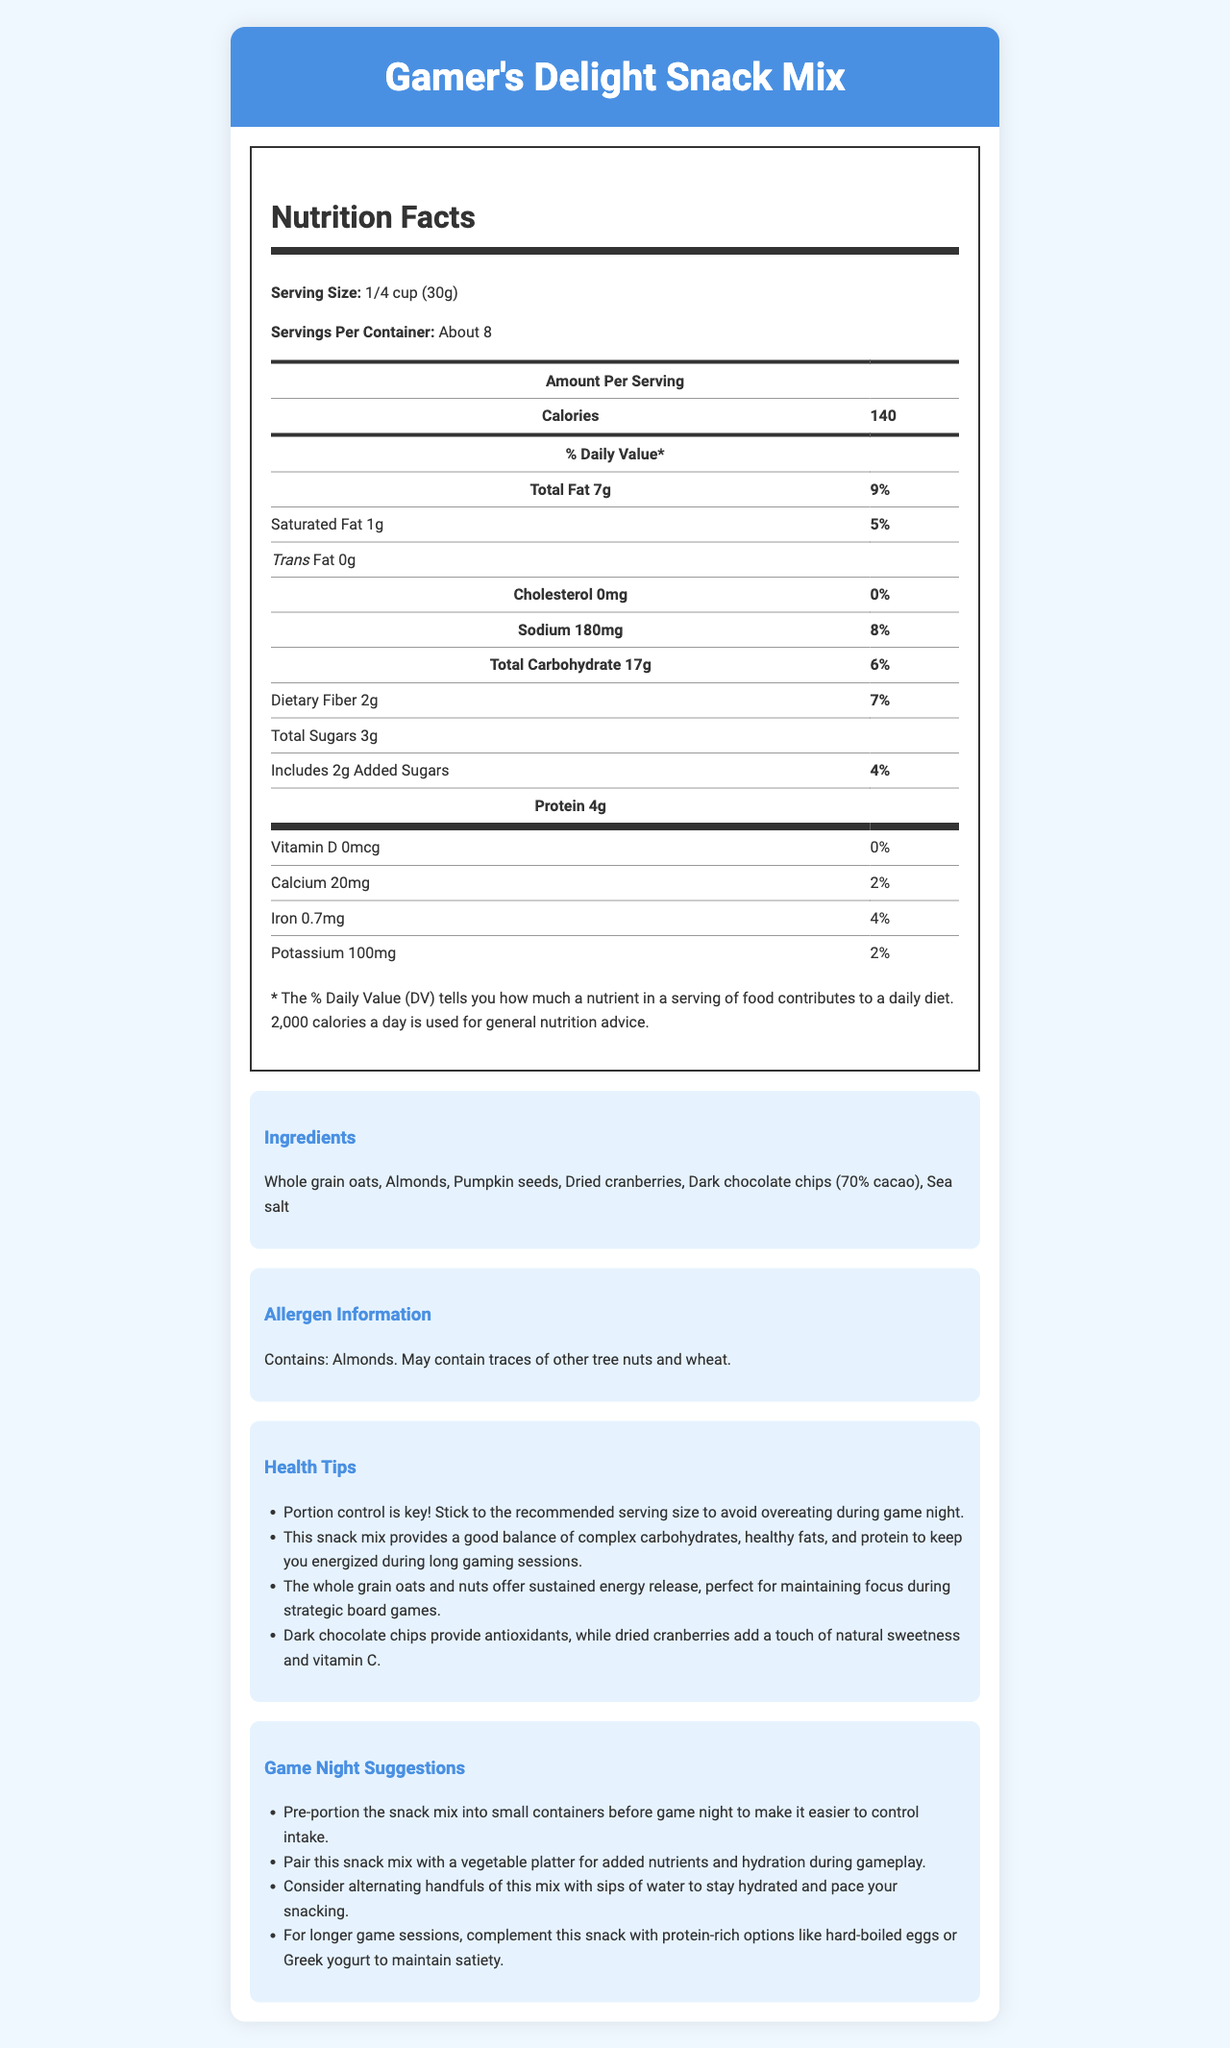What is the serving size for the Gamer's Delight Snack Mix? The serving size is explicitly listed under the nutrition facts section as "1/4 cup (30g)."
Answer: 1/4 cup (30g) How many servings are in one container of the Gamer's Delight Snack Mix? It is stated in the nutrition facts section that there are "About 8" servings per container.
Answer: About 8 How many calories are there per serving of the Gamer's Delight Snack Mix? The number of calories per serving is listed in the nutrition facts as 140.
Answer: 140 calories What is the amount of total fat in one serving of the snack mix? The nutrition facts state that the total fat per serving is 7 grams.
Answer: 7g How much protein is in a serving of Gamer's Delight Snack Mix? The document lists "Protein: 4g" in the nutrition facts section.
Answer: 4g What is the daily value percentage of dietary fiber in one serving? A. 4% B. 7% C. 9% D. 12% According to the nutrition facts, the daily value percentage of dietary fiber is 7%.
Answer: B. 7% Which ingredient is NOT listed in the Gamer's Delight Snack Mix? A. Almonds B. Pumpkin seeds C. Raisins D. Dark chocolate chips The ingredients listed are whole grain oats, almonds, pumpkin seeds, dried cranberries, dark chocolate chips, and sea salt. Raisins are not mentioned.
Answer: C. Raisins Does the snack mix contain any trans fat? The nutrition facts indicate that there are 0 grams of trans fat per serving.
Answer: No Describe the main emphasis of the health tips provided for the Gamer's Delight Snack Mix. The health tips highlight the importance of portion control, balanced nutrition from complex carbohydrates, healthy fats, and protein for sustained energy, and specific benefits such as antioxidants from dark chocolate and vitamin C from dried cranberries.
Answer: Portion control and balanced nutrition for sustained energy Is the snack mix suitable for someone with a nut allergy? The allergen information indicates that the snack mix contains almonds and may contain traces of other tree nuts, making it unsuitable for those with nut allergies.
Answer: No What percentage of the daily value for iron does one serving of the snack mix provide? The document states that each serving provides 4% of the daily value for iron.
Answer: 4% What is the recommended way to control portion sizes during game night according to the document? One of the game night suggestions is to pre-portion the snack mix into small containers to make it easier to control intake.
Answer: Pre-portion the snack mix into small containers How many grams of added sugars does one serving of the snack mix contain? The nutrition facts list 2 grams of added sugars per serving.
Answer: 2g Which of the following best describes the range of nutrients provided by a serving of Gamer's Delight Snack Mix? A. High in cholesterol and sodium B. Rich in vitamins and minerals C. Balanced in fats, fibers, and proteins The snack mix provides 7g of total fat, 2g of dietary fiber, and 4g of protein per serving, indicating a balanced nutrient composition.
Answer: C. Balanced in fats, fibers, and proteins What is the total amount of sodium in a serving of the snack mix? The nutrition facts indicate that there are 180mg of sodium per serving.
Answer: 180mg Does the document provide the manufacturing date of the snack mix? The document does not include any details about the manufacturing or expiration date of the snack mix.
Answer: Not enough information What is the primary source of natural sweetness in the Gamer's Delight Snack Mix? The health tips mention that dried cranberries add a touch of natural sweetness.
Answer: Dried cranberries How much saturated fat is in one serving of the snack mix? The nutrition facts list the amount of saturated fat per serving as 1 gram.
Answer: 1g What additional food items are suggested to pair with the snack mix for added nutrients and hydration during gameplay? The game night suggestions recommend pairing the snack mix with a vegetable platter for added nutrients and hydration.
Answer: Vegetable platter 